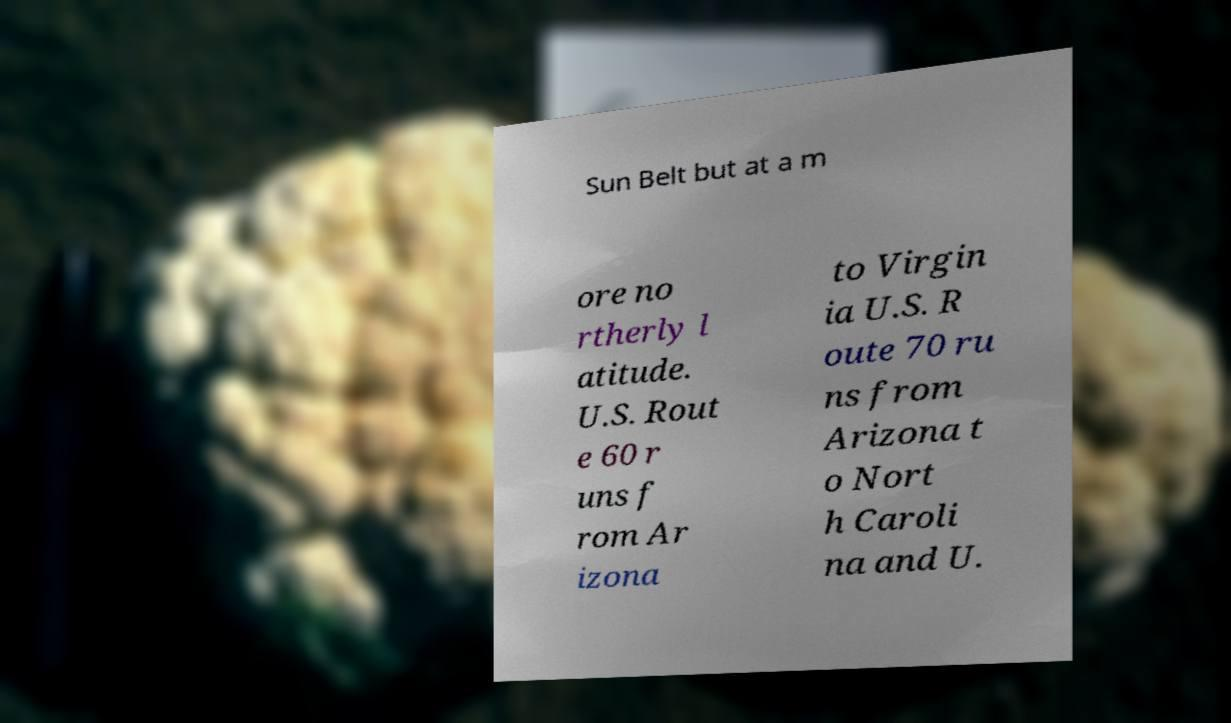Please identify and transcribe the text found in this image. Sun Belt but at a m ore no rtherly l atitude. U.S. Rout e 60 r uns f rom Ar izona to Virgin ia U.S. R oute 70 ru ns from Arizona t o Nort h Caroli na and U. 